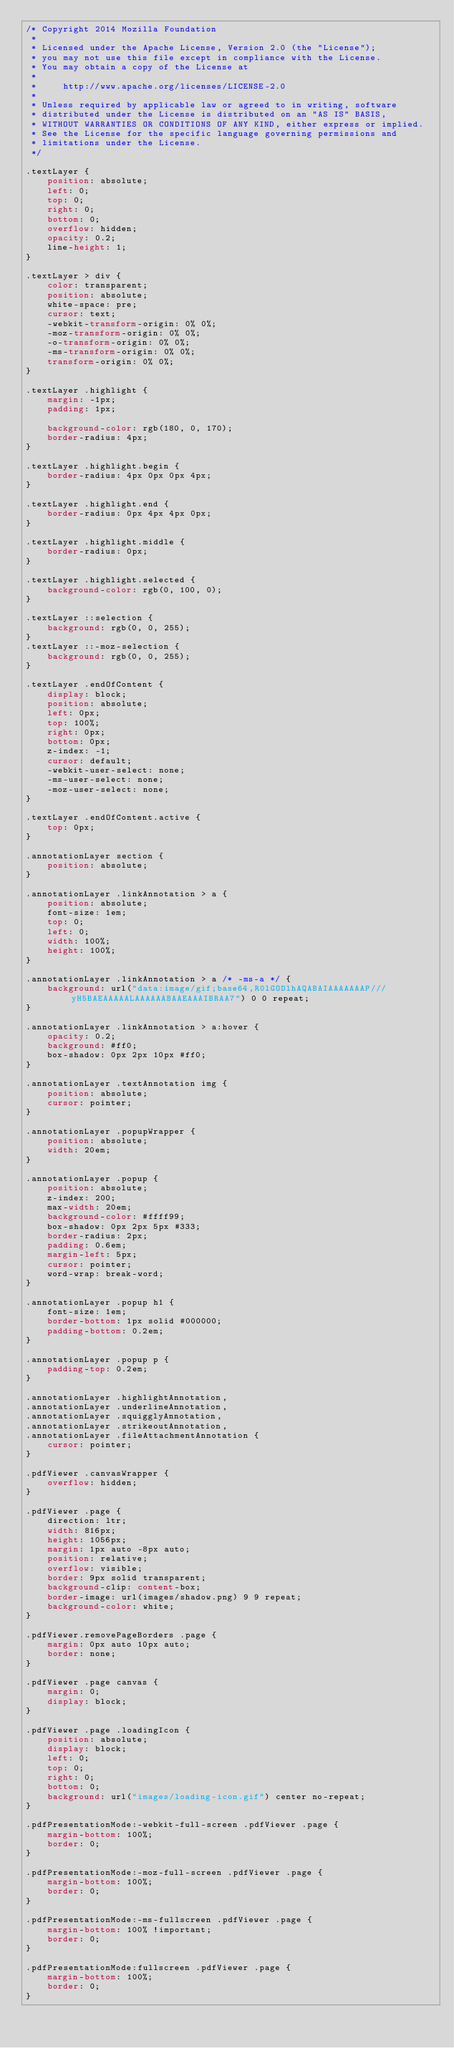<code> <loc_0><loc_0><loc_500><loc_500><_CSS_>/* Copyright 2014 Mozilla Foundation
 *
 * Licensed under the Apache License, Version 2.0 (the "License");
 * you may not use this file except in compliance with the License.
 * You may obtain a copy of the License at
 *
 *     http://www.apache.org/licenses/LICENSE-2.0
 *
 * Unless required by applicable law or agreed to in writing, software
 * distributed under the License is distributed on an "AS IS" BASIS,
 * WITHOUT WARRANTIES OR CONDITIONS OF ANY KIND, either express or implied.
 * See the License for the specific language governing permissions and
 * limitations under the License.
 */

.textLayer {
    position: absolute;
    left: 0;
    top: 0;
    right: 0;
    bottom: 0;
    overflow: hidden;
    opacity: 0.2;
    line-height: 1;
}

.textLayer > div {
    color: transparent;
    position: absolute;
    white-space: pre;
    cursor: text;
    -webkit-transform-origin: 0% 0%;
    -moz-transform-origin: 0% 0%;
    -o-transform-origin: 0% 0%;
    -ms-transform-origin: 0% 0%;
    transform-origin: 0% 0%;
}

.textLayer .highlight {
    margin: -1px;
    padding: 1px;

    background-color: rgb(180, 0, 170);
    border-radius: 4px;
}

.textLayer .highlight.begin {
    border-radius: 4px 0px 0px 4px;
}

.textLayer .highlight.end {
    border-radius: 0px 4px 4px 0px;
}

.textLayer .highlight.middle {
    border-radius: 0px;
}

.textLayer .highlight.selected {
    background-color: rgb(0, 100, 0);
}

.textLayer ::selection {
    background: rgb(0, 0, 255);
}
.textLayer ::-moz-selection {
    background: rgb(0, 0, 255);
}

.textLayer .endOfContent {
    display: block;
    position: absolute;
    left: 0px;
    top: 100%;
    right: 0px;
    bottom: 0px;
    z-index: -1;
    cursor: default;
    -webkit-user-select: none;
    -ms-user-select: none;
    -moz-user-select: none;
}

.textLayer .endOfContent.active {
    top: 0px;
}

.annotationLayer section {
    position: absolute;
}

.annotationLayer .linkAnnotation > a {
    position: absolute;
    font-size: 1em;
    top: 0;
    left: 0;
    width: 100%;
    height: 100%;
}

.annotationLayer .linkAnnotation > a /* -ms-a */ {
    background: url("data:image/gif;base64,R0lGODlhAQABAIAAAAAAAP///yH5BAEAAAAALAAAAAABAAEAAAIBRAA7") 0 0 repeat;
}

.annotationLayer .linkAnnotation > a:hover {
    opacity: 0.2;
    background: #ff0;
    box-shadow: 0px 2px 10px #ff0;
}

.annotationLayer .textAnnotation img {
    position: absolute;
    cursor: pointer;
}

.annotationLayer .popupWrapper {
    position: absolute;
    width: 20em;
}

.annotationLayer .popup {
    position: absolute;
    z-index: 200;
    max-width: 20em;
    background-color: #ffff99;
    box-shadow: 0px 2px 5px #333;
    border-radius: 2px;
    padding: 0.6em;
    margin-left: 5px;
    cursor: pointer;
    word-wrap: break-word;
}

.annotationLayer .popup h1 {
    font-size: 1em;
    border-bottom: 1px solid #000000;
    padding-bottom: 0.2em;
}

.annotationLayer .popup p {
    padding-top: 0.2em;
}

.annotationLayer .highlightAnnotation,
.annotationLayer .underlineAnnotation,
.annotationLayer .squigglyAnnotation,
.annotationLayer .strikeoutAnnotation,
.annotationLayer .fileAttachmentAnnotation {
    cursor: pointer;
}

.pdfViewer .canvasWrapper {
    overflow: hidden;
}

.pdfViewer .page {
    direction: ltr;
    width: 816px;
    height: 1056px;
    margin: 1px auto -8px auto;
    position: relative;
    overflow: visible;
    border: 9px solid transparent;
    background-clip: content-box;
    border-image: url(images/shadow.png) 9 9 repeat;
    background-color: white;
}

.pdfViewer.removePageBorders .page {
    margin: 0px auto 10px auto;
    border: none;
}

.pdfViewer .page canvas {
    margin: 0;
    display: block;
}

.pdfViewer .page .loadingIcon {
    position: absolute;
    display: block;
    left: 0;
    top: 0;
    right: 0;
    bottom: 0;
    background: url("images/loading-icon.gif") center no-repeat;
}

.pdfPresentationMode:-webkit-full-screen .pdfViewer .page {
    margin-bottom: 100%;
    border: 0;
}

.pdfPresentationMode:-moz-full-screen .pdfViewer .page {
    margin-bottom: 100%;
    border: 0;
}

.pdfPresentationMode:-ms-fullscreen .pdfViewer .page {
    margin-bottom: 100% !important;
    border: 0;
}

.pdfPresentationMode:fullscreen .pdfViewer .page {
    margin-bottom: 100%;
    border: 0;
}
</code> 